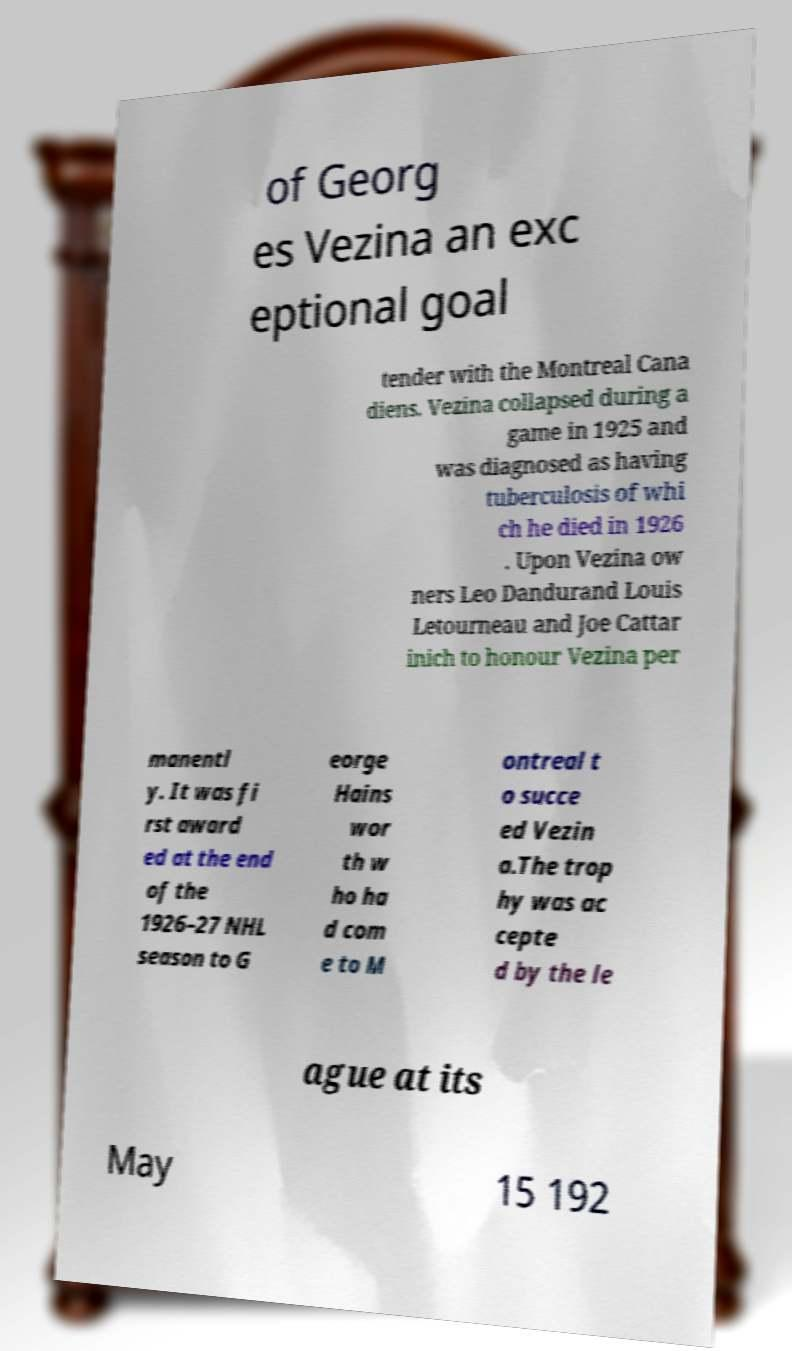Please identify and transcribe the text found in this image. of Georg es Vezina an exc eptional goal tender with the Montreal Cana diens. Vezina collapsed during a game in 1925 and was diagnosed as having tuberculosis of whi ch he died in 1926 . Upon Vezina ow ners Leo Dandurand Louis Letourneau and Joe Cattar inich to honour Vezina per manentl y. It was fi rst award ed at the end of the 1926–27 NHL season to G eorge Hains wor th w ho ha d com e to M ontreal t o succe ed Vezin a.The trop hy was ac cepte d by the le ague at its May 15 192 